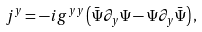Convert formula to latex. <formula><loc_0><loc_0><loc_500><loc_500>j ^ { y } = - i g ^ { y y } \left ( { \bar { \Psi } } \partial _ { y } \Psi - \Psi \partial _ { y } { \bar { \Psi } } \right ) ,</formula> 